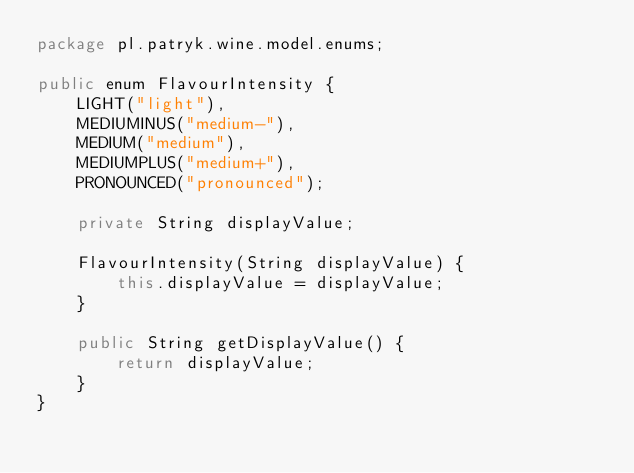Convert code to text. <code><loc_0><loc_0><loc_500><loc_500><_Java_>package pl.patryk.wine.model.enums;

public enum FlavourIntensity {
    LIGHT("light"),
    MEDIUMINUS("medium-"),
    MEDIUM("medium"),
    MEDIUMPLUS("medium+"),
    PRONOUNCED("pronounced");

    private String displayValue;

    FlavourIntensity(String displayValue) {
        this.displayValue = displayValue;
    }

    public String getDisplayValue() {
        return displayValue;
    }
}
</code> 